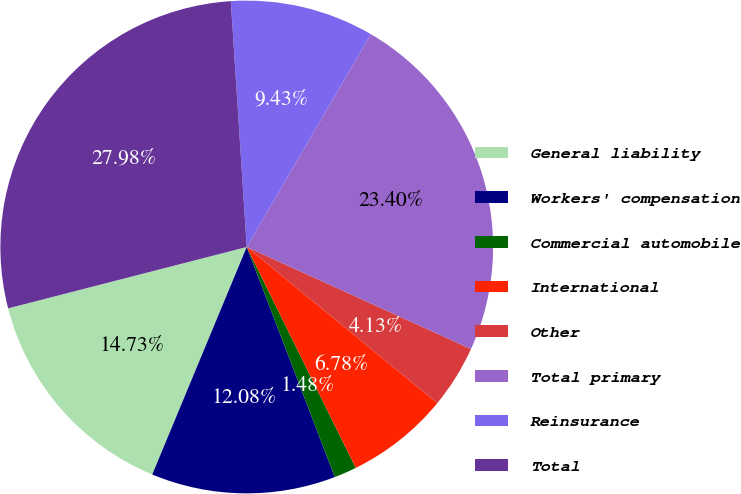Convert chart. <chart><loc_0><loc_0><loc_500><loc_500><pie_chart><fcel>General liability<fcel>Workers' compensation<fcel>Commercial automobile<fcel>International<fcel>Other<fcel>Total primary<fcel>Reinsurance<fcel>Total<nl><fcel>14.73%<fcel>12.08%<fcel>1.48%<fcel>6.78%<fcel>4.13%<fcel>23.4%<fcel>9.43%<fcel>27.98%<nl></chart> 